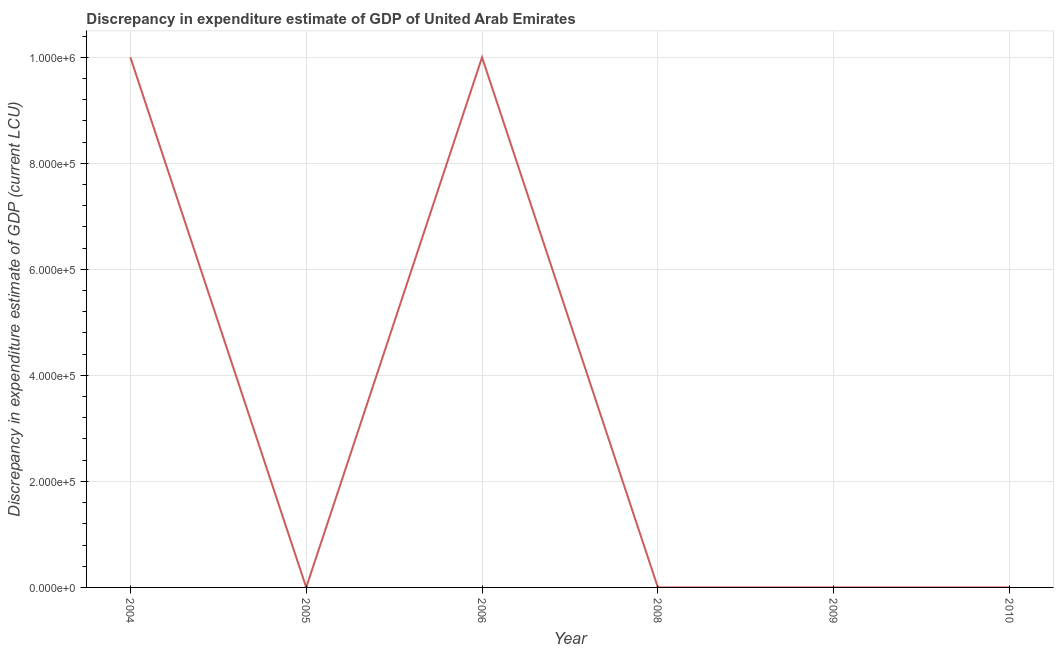What is the discrepancy in expenditure estimate of gdp in 2009?
Offer a terse response. 0. Across all years, what is the maximum discrepancy in expenditure estimate of gdp?
Ensure brevity in your answer.  1.00e+06. Across all years, what is the minimum discrepancy in expenditure estimate of gdp?
Your answer should be compact. 0. In which year was the discrepancy in expenditure estimate of gdp maximum?
Give a very brief answer. 2004. What is the sum of the discrepancy in expenditure estimate of gdp?
Your answer should be compact. 2.00e+06. What is the difference between the discrepancy in expenditure estimate of gdp in 2005 and 2009?
Make the answer very short. -0. What is the average discrepancy in expenditure estimate of gdp per year?
Offer a very short reply. 3.33e+05. What is the median discrepancy in expenditure estimate of gdp?
Give a very brief answer. 0. What is the ratio of the discrepancy in expenditure estimate of gdp in 2004 to that in 2009?
Keep it short and to the point. 4.44e+09. What is the difference between the highest and the second highest discrepancy in expenditure estimate of gdp?
Your answer should be very brief. 5.200004670768976e-5. What is the difference between the highest and the lowest discrepancy in expenditure estimate of gdp?
Ensure brevity in your answer.  1.00e+06. How many years are there in the graph?
Ensure brevity in your answer.  6. Are the values on the major ticks of Y-axis written in scientific E-notation?
Provide a short and direct response. Yes. Does the graph contain any zero values?
Provide a short and direct response. Yes. Does the graph contain grids?
Keep it short and to the point. Yes. What is the title of the graph?
Provide a short and direct response. Discrepancy in expenditure estimate of GDP of United Arab Emirates. What is the label or title of the Y-axis?
Provide a short and direct response. Discrepancy in expenditure estimate of GDP (current LCU). What is the Discrepancy in expenditure estimate of GDP (current LCU) of 2004?
Keep it short and to the point. 1.00e+06. What is the Discrepancy in expenditure estimate of GDP (current LCU) of 2005?
Your answer should be compact. 8e-6. What is the Discrepancy in expenditure estimate of GDP (current LCU) in 2006?
Provide a short and direct response. 1.00e+06. What is the Discrepancy in expenditure estimate of GDP (current LCU) of 2008?
Your answer should be very brief. 0. What is the Discrepancy in expenditure estimate of GDP (current LCU) of 2009?
Offer a terse response. 0. What is the Discrepancy in expenditure estimate of GDP (current LCU) in 2010?
Ensure brevity in your answer.  0. What is the difference between the Discrepancy in expenditure estimate of GDP (current LCU) in 2004 and 2005?
Provide a short and direct response. 1.00e+06. What is the difference between the Discrepancy in expenditure estimate of GDP (current LCU) in 2004 and 2006?
Make the answer very short. 5e-5. What is the difference between the Discrepancy in expenditure estimate of GDP (current LCU) in 2004 and 2009?
Keep it short and to the point. 1.00e+06. What is the difference between the Discrepancy in expenditure estimate of GDP (current LCU) in 2005 and 2006?
Ensure brevity in your answer.  -1.00e+06. What is the difference between the Discrepancy in expenditure estimate of GDP (current LCU) in 2005 and 2009?
Your answer should be very brief. -0. What is the difference between the Discrepancy in expenditure estimate of GDP (current LCU) in 2006 and 2009?
Make the answer very short. 1.00e+06. What is the ratio of the Discrepancy in expenditure estimate of GDP (current LCU) in 2004 to that in 2005?
Keep it short and to the point. 1.25e+11. What is the ratio of the Discrepancy in expenditure estimate of GDP (current LCU) in 2004 to that in 2006?
Keep it short and to the point. 1. What is the ratio of the Discrepancy in expenditure estimate of GDP (current LCU) in 2004 to that in 2009?
Your response must be concise. 4.44e+09. What is the ratio of the Discrepancy in expenditure estimate of GDP (current LCU) in 2005 to that in 2009?
Your answer should be compact. 0.04. What is the ratio of the Discrepancy in expenditure estimate of GDP (current LCU) in 2006 to that in 2009?
Your answer should be very brief. 4.44e+09. 